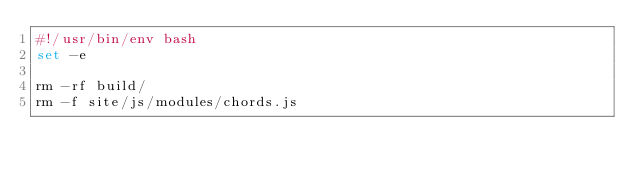<code> <loc_0><loc_0><loc_500><loc_500><_Bash_>#!/usr/bin/env bash
set -e

rm -rf build/
rm -f site/js/modules/chords.js
</code> 